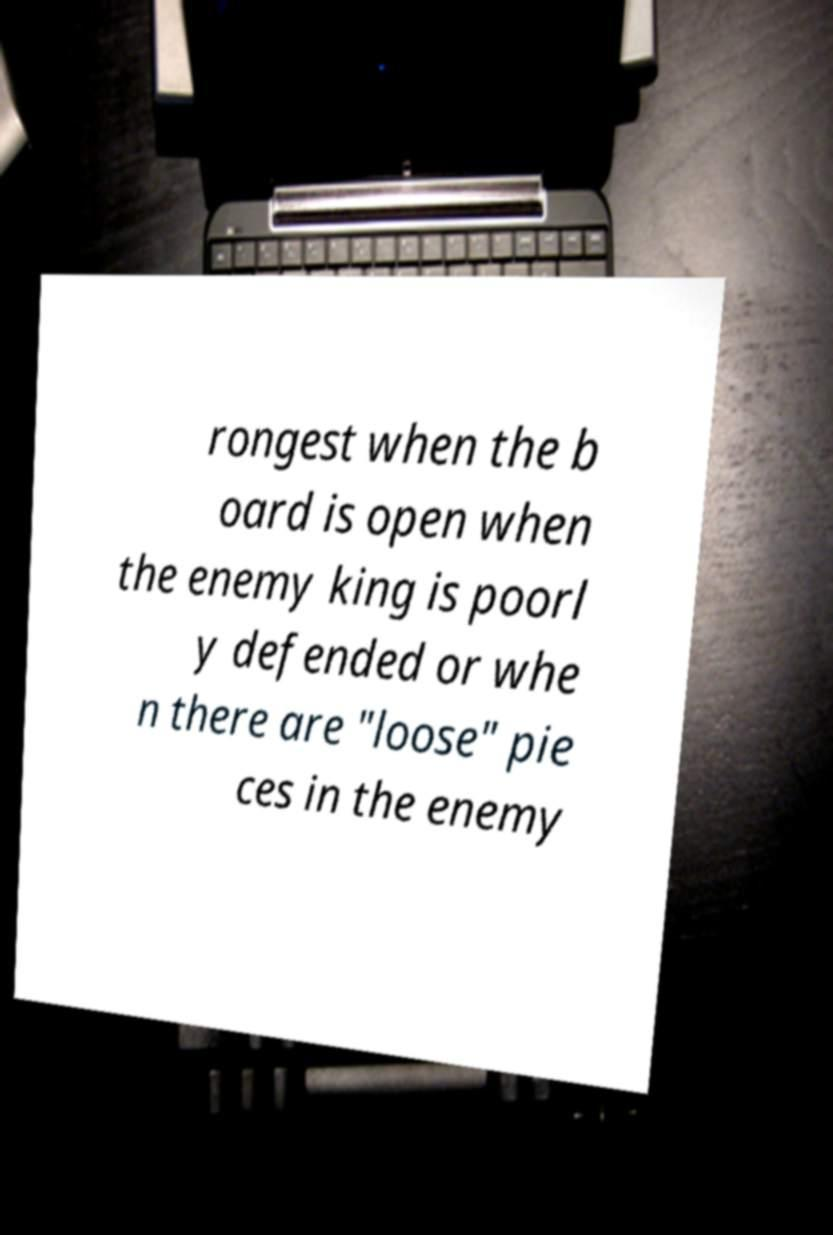Please read and relay the text visible in this image. What does it say? rongest when the b oard is open when the enemy king is poorl y defended or whe n there are "loose" pie ces in the enemy 